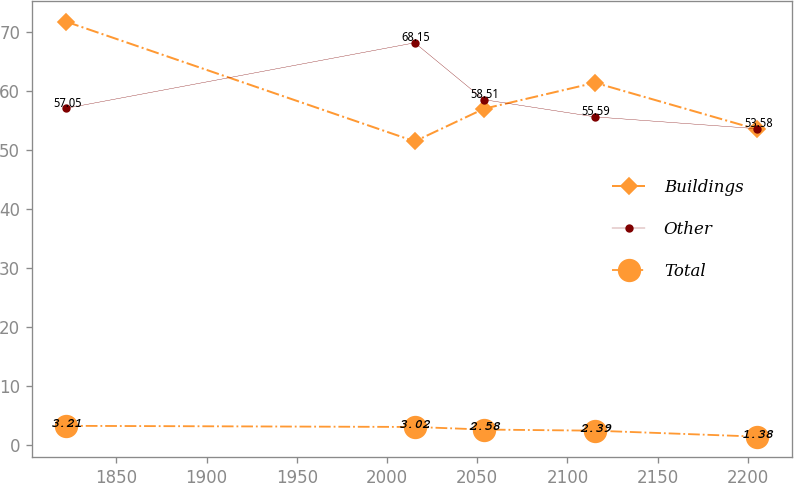<chart> <loc_0><loc_0><loc_500><loc_500><line_chart><ecel><fcel>Buildings<fcel>Other<fcel>Total<nl><fcel>1822.26<fcel>71.72<fcel>57.05<fcel>3.21<nl><fcel>2015.37<fcel>51.44<fcel>68.15<fcel>3.02<nl><fcel>2053.66<fcel>56.96<fcel>58.51<fcel>2.58<nl><fcel>2115.29<fcel>61.38<fcel>55.59<fcel>2.39<nl><fcel>2205.21<fcel>53.47<fcel>53.58<fcel>1.38<nl></chart> 